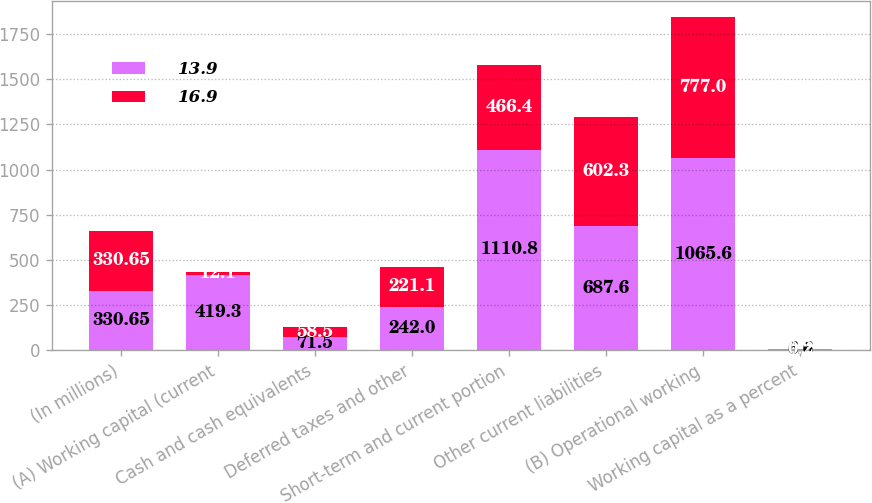<chart> <loc_0><loc_0><loc_500><loc_500><stacked_bar_chart><ecel><fcel>(In millions)<fcel>(A) Working capital (current<fcel>Cash and cash equivalents<fcel>Deferred taxes and other<fcel>Short-term and current portion<fcel>Other current liabilities<fcel>(B) Operational working<fcel>Working capital as a percent<nl><fcel>13.9<fcel>330.65<fcel>419.3<fcel>71.5<fcel>242<fcel>1110.8<fcel>687.6<fcel>1065.6<fcel>6.6<nl><fcel>16.9<fcel>330.65<fcel>12.1<fcel>58.5<fcel>221.1<fcel>466.4<fcel>602.3<fcel>777<fcel>0.2<nl></chart> 